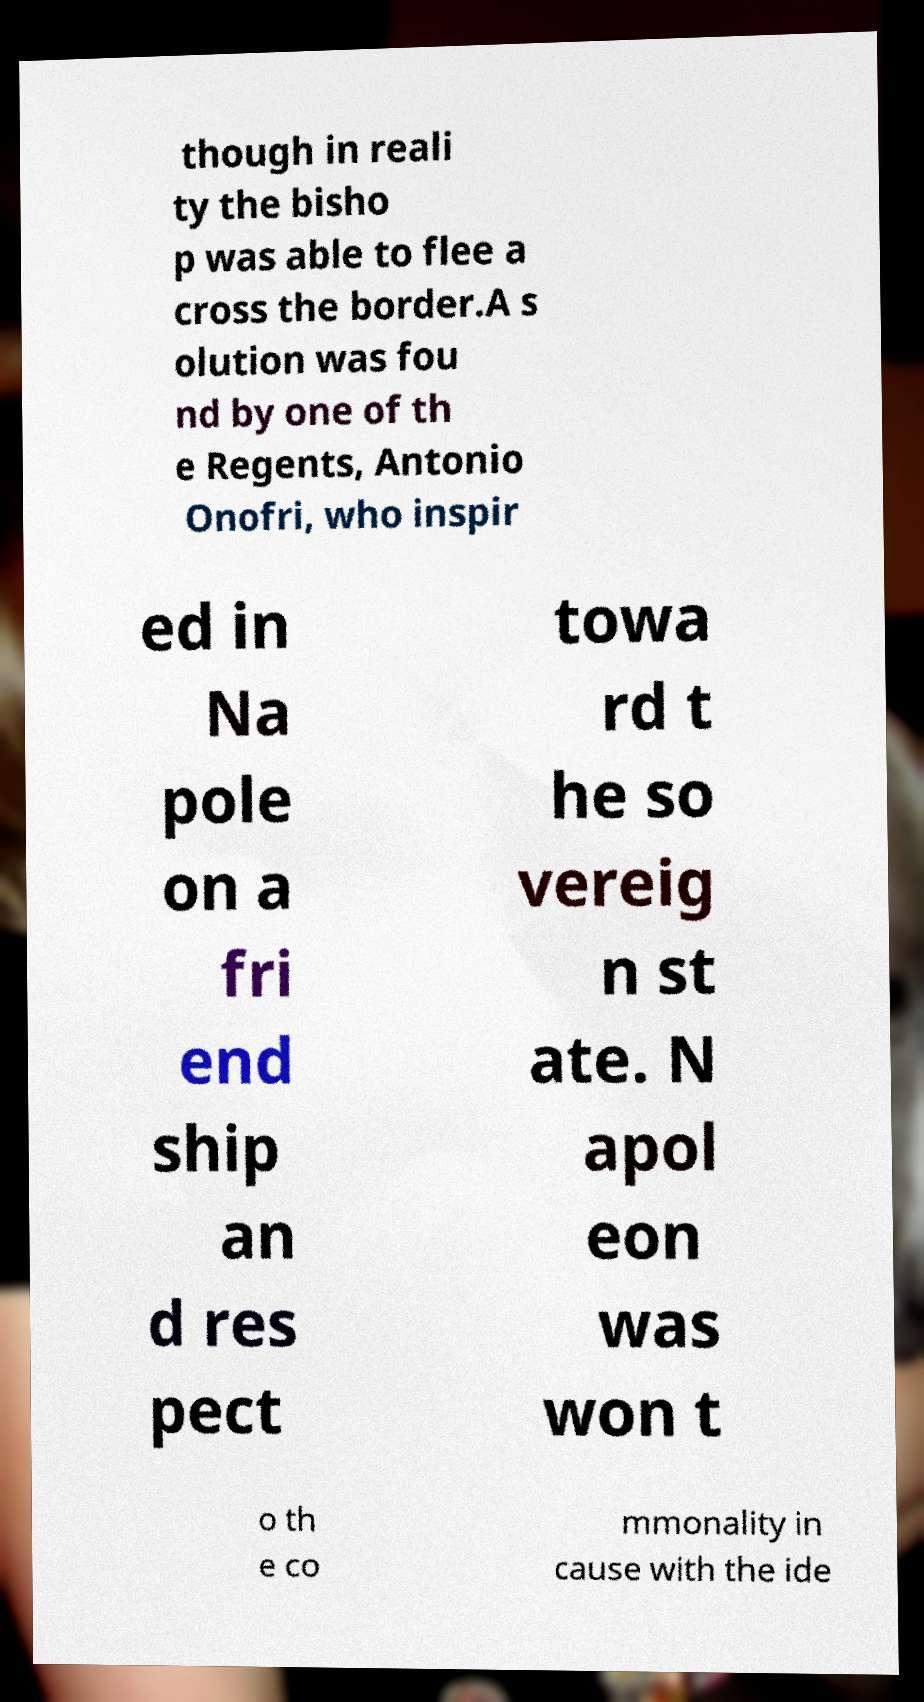Please identify and transcribe the text found in this image. though in reali ty the bisho p was able to flee a cross the border.A s olution was fou nd by one of th e Regents, Antonio Onofri, who inspir ed in Na pole on a fri end ship an d res pect towa rd t he so vereig n st ate. N apol eon was won t o th e co mmonality in cause with the ide 